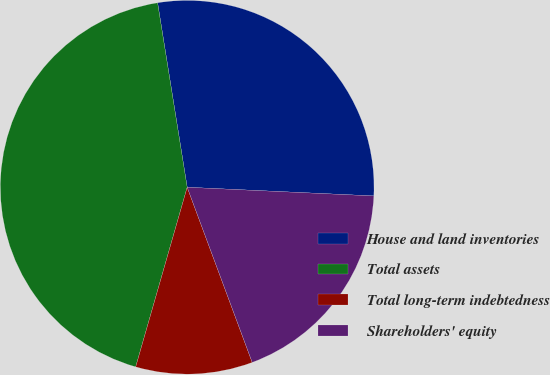<chart> <loc_0><loc_0><loc_500><loc_500><pie_chart><fcel>House and land inventories<fcel>Total assets<fcel>Total long-term indebtedness<fcel>Shareholders' equity<nl><fcel>28.27%<fcel>43.02%<fcel>10.1%<fcel>18.6%<nl></chart> 